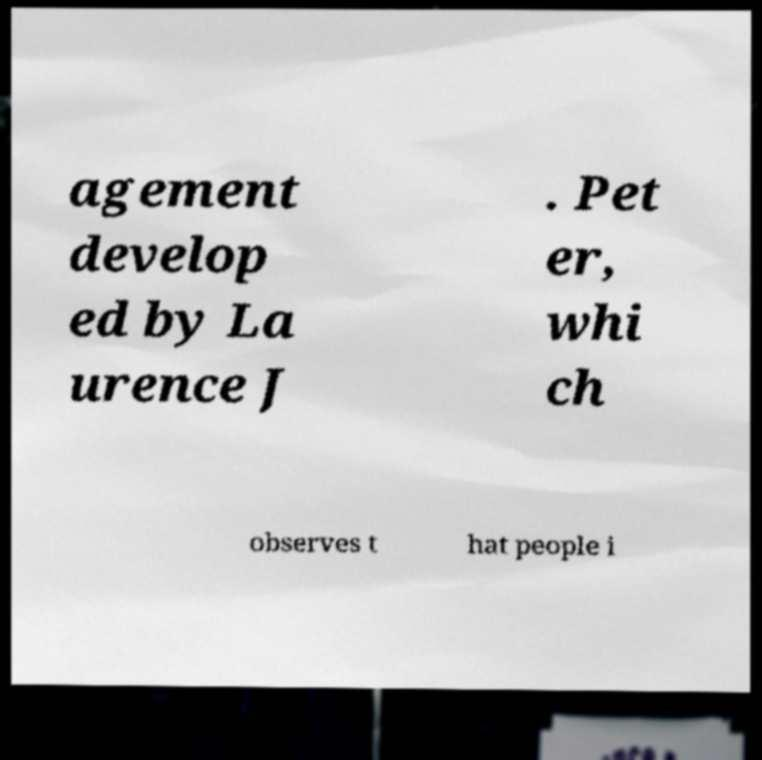Can you read and provide the text displayed in the image?This photo seems to have some interesting text. Can you extract and type it out for me? agement develop ed by La urence J . Pet er, whi ch observes t hat people i 